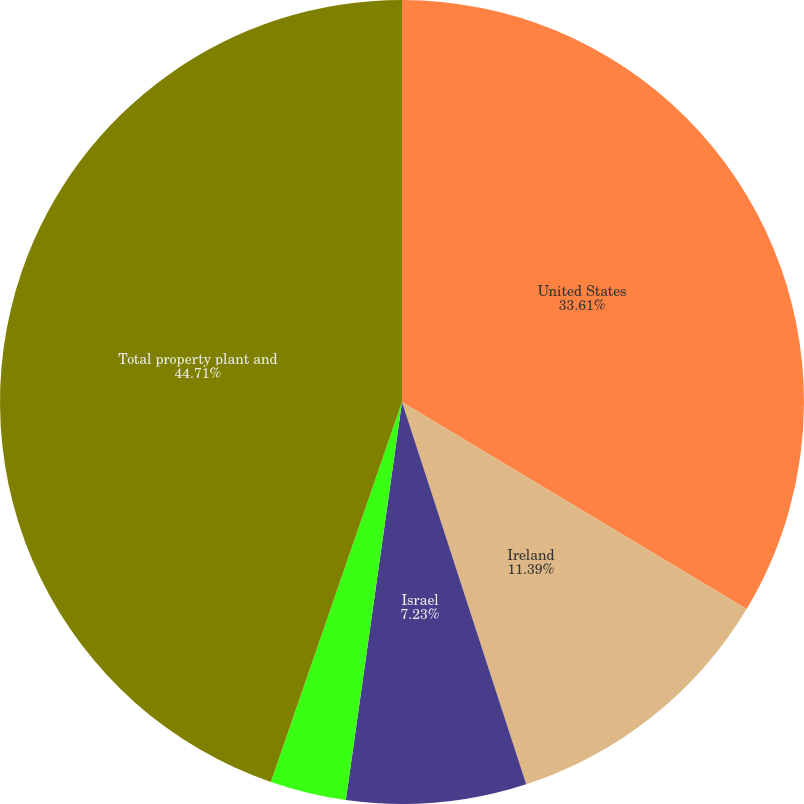Convert chart. <chart><loc_0><loc_0><loc_500><loc_500><pie_chart><fcel>United States<fcel>Ireland<fcel>Israel<fcel>Other countries<fcel>Total property plant and<nl><fcel>33.61%<fcel>11.39%<fcel>7.23%<fcel>3.06%<fcel>44.71%<nl></chart> 